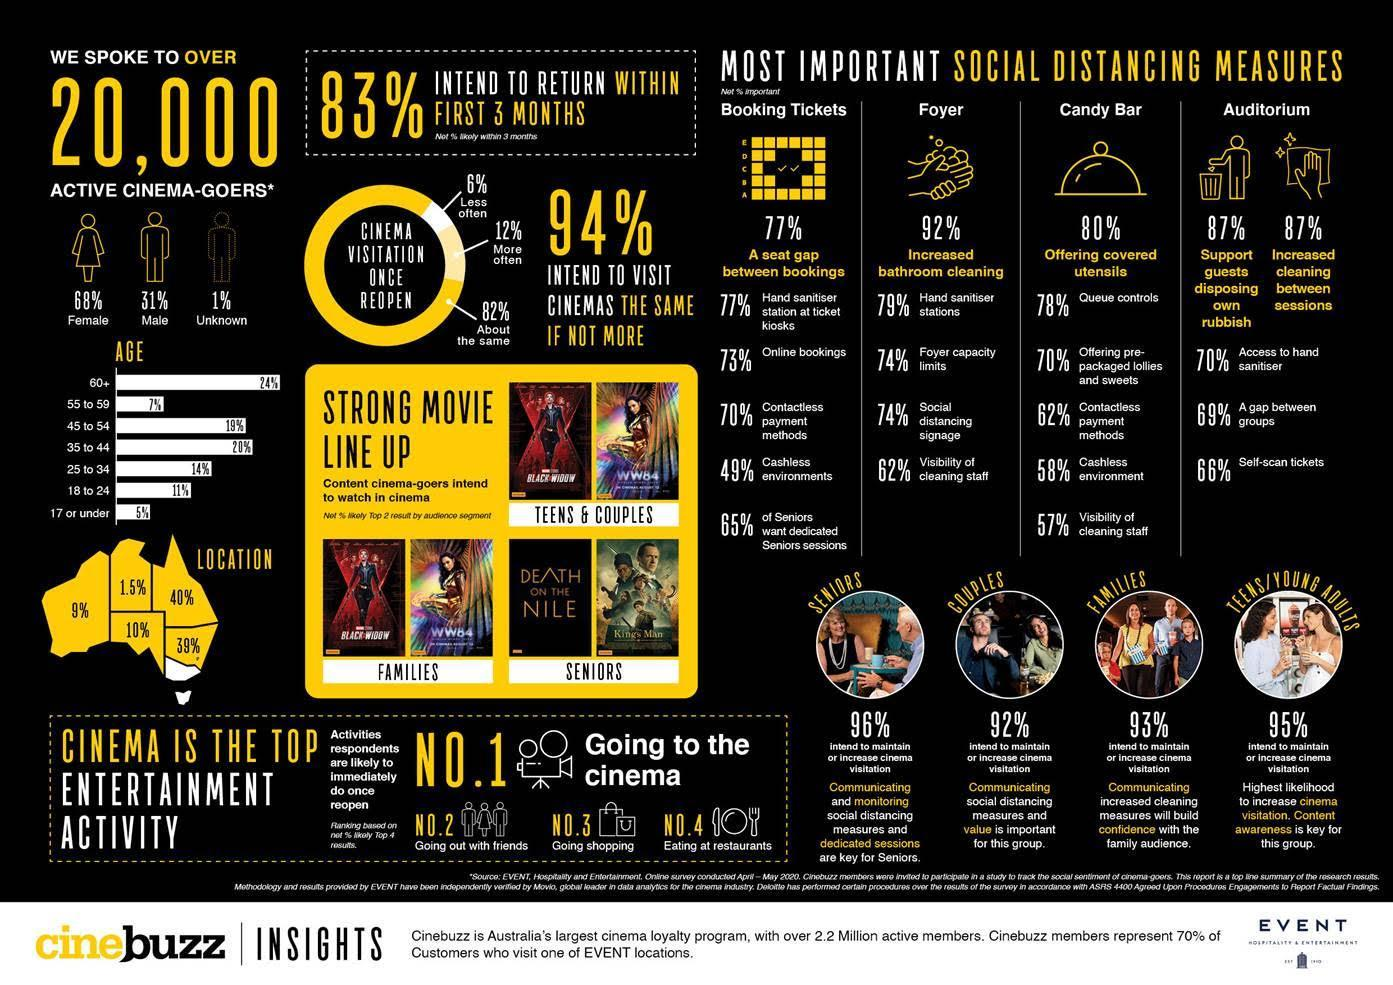Which age group has the highest percentage of cinema-goers as per the Cinebuzz insights?
Answer the question with a short phrase. 60+ Out of 20,000 active cinema-goers, what percentage of them constitute the females? 68% Out of 20,000 active cinema-goers, what percentage of them constitute the males? 31% What percentage of couples intend to maintain or increase cinema visitation as per the cinebuzz insights? 92% What is the top no.3 entertainment activity according to the activities respondents once it's reopened? Going shopping What is the top no.4 entertainment activity according to the activities respondents once it's reopened? Eating at restaurants What percentage of people intend to visit cinemas more often as per the cinebuzz insights? 12% 